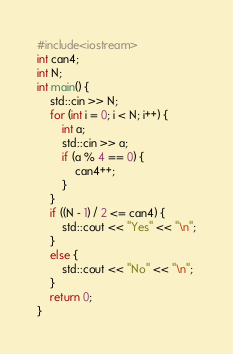<code> <loc_0><loc_0><loc_500><loc_500><_C++_>#include<iostream>
int can4;
int N;
int main() {
	std::cin >> N;
	for (int i = 0; i < N; i++) {
		int a;
		std::cin >> a;
		if (a % 4 == 0) {
			can4++;
		}
	}
	if ((N - 1) / 2 <= can4) {
		std::cout << "Yes" << "\n";
	}
	else {
		std::cout << "No" << "\n";
	}
	return 0;
}</code> 